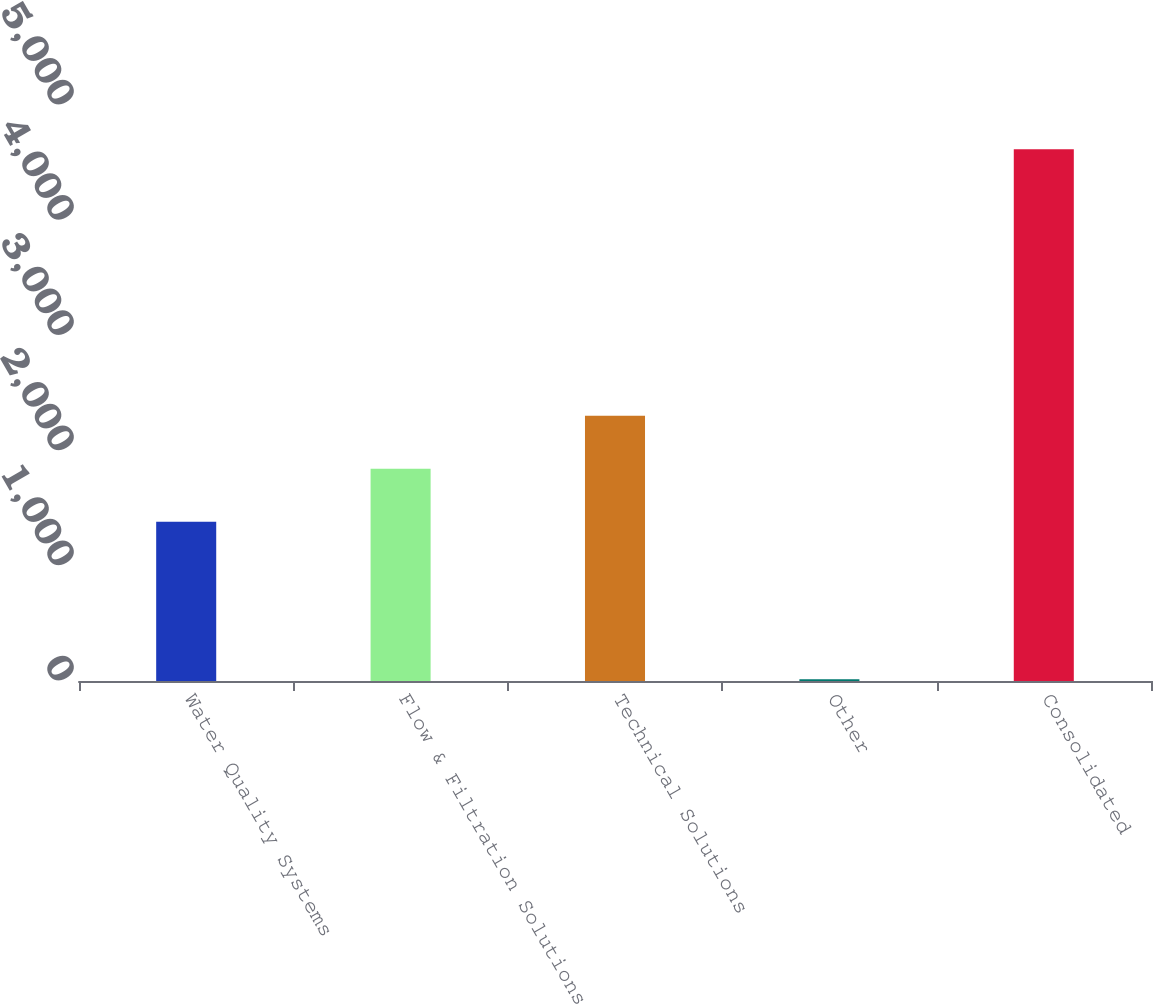Convert chart. <chart><loc_0><loc_0><loc_500><loc_500><bar_chart><fcel>Water Quality Systems<fcel>Flow & Filtration Solutions<fcel>Technical Solutions<fcel>Other<fcel>Consolidated<nl><fcel>1381.5<fcel>1841.54<fcel>2301.58<fcel>16<fcel>4616.4<nl></chart> 